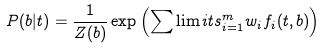Convert formula to latex. <formula><loc_0><loc_0><loc_500><loc_500>P ( b | t ) = \frac { 1 } { Z ( b ) } \exp \left ( \sum \lim i t s _ { i = 1 } ^ { m } w _ { i } f _ { i } ( t , b ) \right )</formula> 